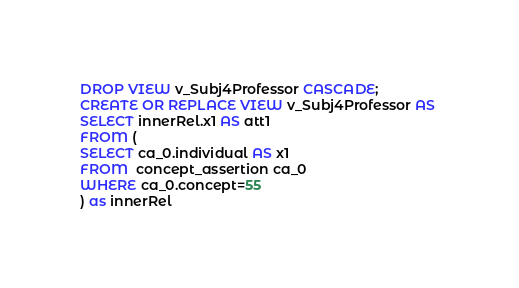Convert code to text. <code><loc_0><loc_0><loc_500><loc_500><_SQL_>DROP VIEW v_Subj4Professor CASCADE;
CREATE OR REPLACE VIEW v_Subj4Professor AS 
SELECT innerRel.x1 AS att1
FROM (
SELECT ca_0.individual AS x1
FROM  concept_assertion ca_0
WHERE ca_0.concept=55
) as innerRel
</code> 